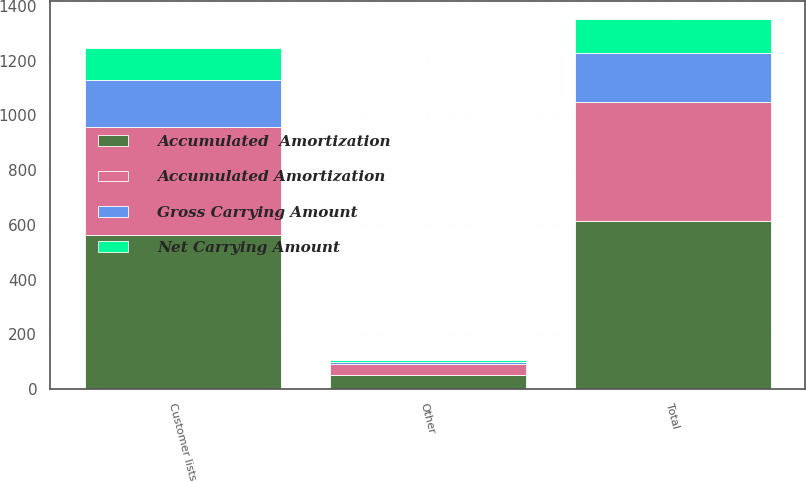Convert chart. <chart><loc_0><loc_0><loc_500><loc_500><stacked_bar_chart><ecel><fcel>Customer lists<fcel>Other<fcel>Total<nl><fcel>Accumulated  Amortization<fcel>564<fcel>50<fcel>614<nl><fcel>Gross Carrying Amount<fcel>170<fcel>10<fcel>180<nl><fcel>Accumulated Amortization<fcel>394<fcel>40<fcel>434<nl><fcel>Net Carrying Amount<fcel>118<fcel>5<fcel>123<nl></chart> 